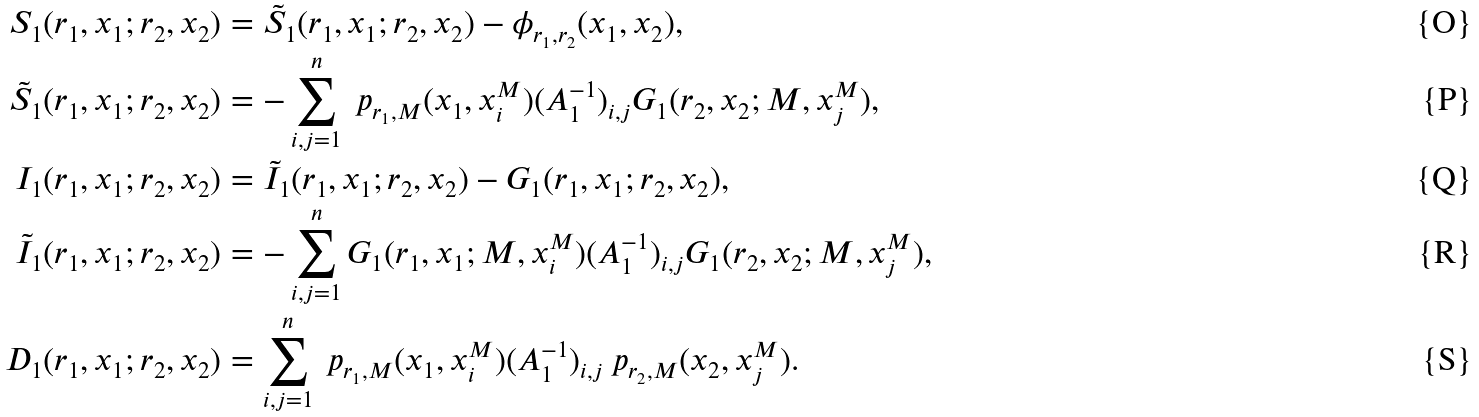Convert formula to latex. <formula><loc_0><loc_0><loc_500><loc_500>S _ { 1 } ( r _ { 1 } , x _ { 1 } ; r _ { 2 } , x _ { 2 } ) & = \tilde { S } _ { 1 } ( r _ { 1 } , x _ { 1 } ; r _ { 2 } , x _ { 2 } ) - \phi _ { r _ { 1 } , r _ { 2 } } ( x _ { 1 } , x _ { 2 } ) , \\ \tilde { S } _ { 1 } ( r _ { 1 } , x _ { 1 } ; r _ { 2 } , x _ { 2 } ) & = - \sum _ { i , j = 1 } ^ { n } \ p _ { r _ { 1 } , M } ( x _ { 1 } , x _ { i } ^ { M } ) ( A _ { 1 } ^ { - 1 } ) _ { i , j } G _ { 1 } ( r _ { 2 } , x _ { 2 } ; M , x _ { j } ^ { M } ) , \\ I _ { 1 } ( r _ { 1 } , x _ { 1 } ; r _ { 2 } , x _ { 2 } ) & = \tilde { I } _ { 1 } ( r _ { 1 } , x _ { 1 } ; r _ { 2 } , x _ { 2 } ) - G _ { 1 } ( r _ { 1 } , x _ { 1 } ; r _ { 2 } , x _ { 2 } ) , \\ \tilde { I } _ { 1 } ( r _ { 1 } , x _ { 1 } ; r _ { 2 } , x _ { 2 } ) & = - \sum _ { i , j = 1 } ^ { n } G _ { 1 } ( r _ { 1 } , x _ { 1 } ; M , x _ { i } ^ { M } ) ( A _ { 1 } ^ { - 1 } ) _ { i , j } G _ { 1 } ( r _ { 2 } , x _ { 2 } ; M , x _ { j } ^ { M } ) , \\ D _ { 1 } ( r _ { 1 } , x _ { 1 } ; r _ { 2 } , x _ { 2 } ) & = \sum _ { i , j = 1 } ^ { n } \ p _ { r _ { 1 } , M } ( x _ { 1 } , x _ { i } ^ { M } ) ( A _ { 1 } ^ { - 1 } ) _ { i , j } \ p _ { r _ { 2 } , M } ( x _ { 2 } , x _ { j } ^ { M } ) .</formula> 